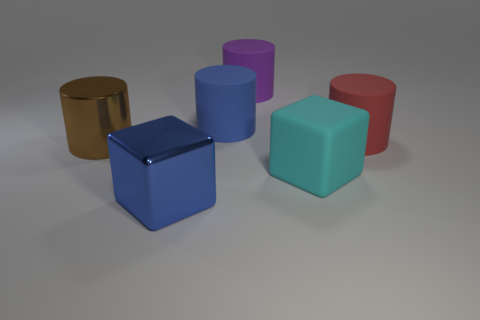There is a large blue object behind the big metallic cylinder; what shape is it?
Offer a terse response. Cylinder. What is the material of the large brown thing that is the same shape as the red object?
Offer a terse response. Metal. There is a rubber cylinder right of the purple cylinder; is its size the same as the purple object?
Your response must be concise. Yes. How many metal things are in front of the big metallic cylinder?
Give a very brief answer. 1. Is the number of cylinders on the left side of the large cyan rubber cube less than the number of large things in front of the big purple thing?
Make the answer very short. Yes. What number of blue cylinders are there?
Provide a succinct answer. 1. What color is the metallic thing that is in front of the large brown metallic thing?
Offer a very short reply. Blue. There is a large metallic cube; is it the same color as the matte thing to the left of the large purple rubber cylinder?
Offer a terse response. Yes. There is a large metallic thing left of the big thing that is in front of the large cyan rubber thing; what is its color?
Your answer should be compact. Brown. Do the large blue object behind the red rubber cylinder and the red rubber object have the same shape?
Ensure brevity in your answer.  Yes. 